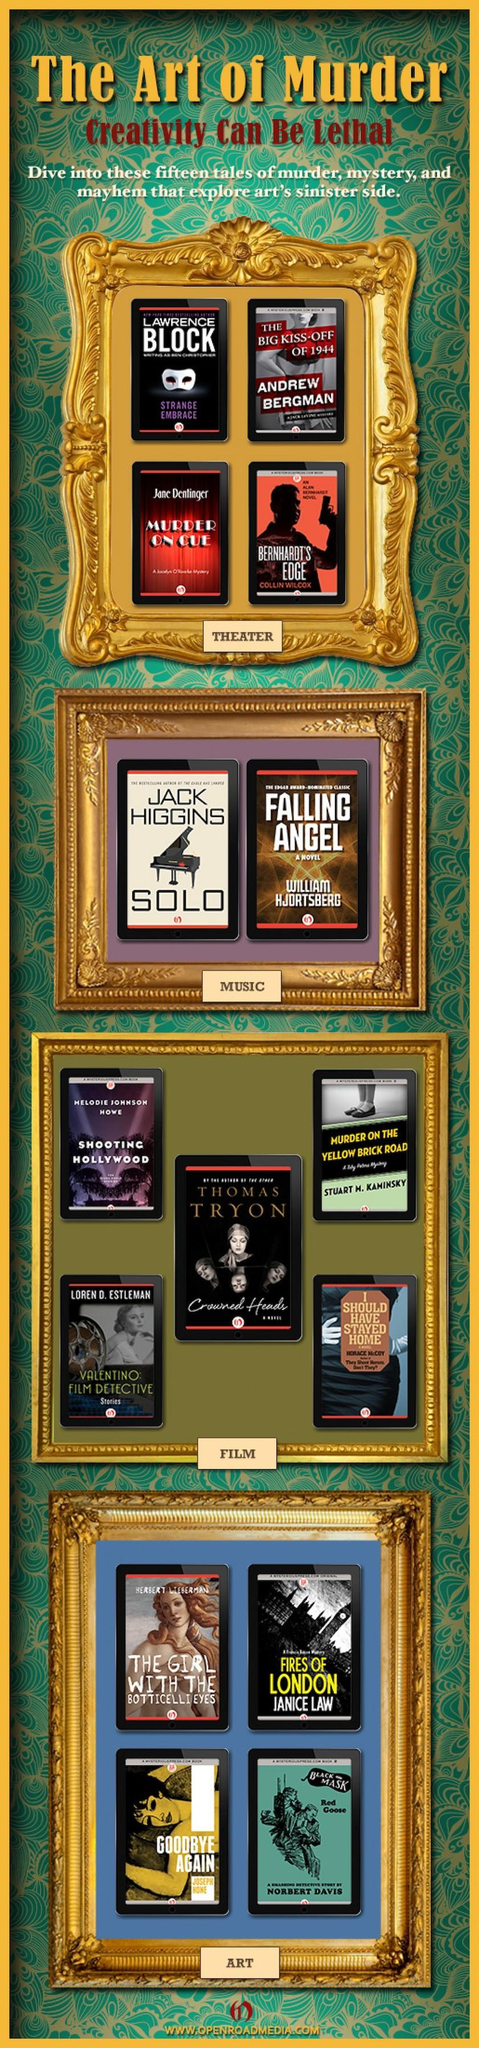Outline some significant characteristics in this image. Out of the books that have a backdrop theme of movies, there are 5 of them. The book with a white eye mask on its cover page is "Strange Embrace. 